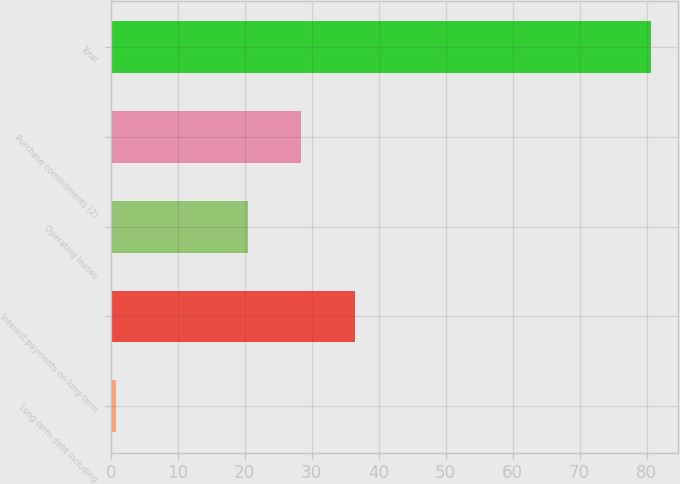Convert chart. <chart><loc_0><loc_0><loc_500><loc_500><bar_chart><fcel>Long-term debt including<fcel>Interest payments on long-term<fcel>Operating leases<fcel>Purchase commitments (2)<fcel>Total<nl><fcel>0.8<fcel>36.46<fcel>20.5<fcel>28.48<fcel>80.6<nl></chart> 